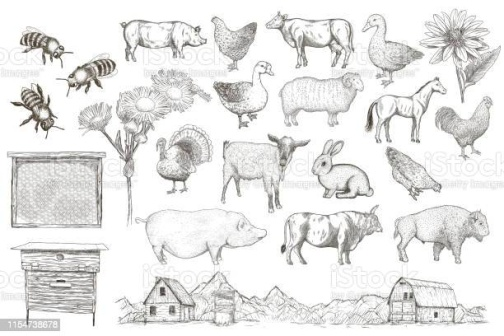Can you tell me more about the significance of the various animals depicted in the image? Absolutely! The animals in the image represent different aspects of farm life, each serving an essential purpose.

The bee is crucial for pollination, which helps crops and flowers grow. The cow provides milk, meat, and sometimes labor for farming tasks. Chickens contribute by laying eggs and also helping control pests. Pigs offer meat and are also known for their intelligence. Sheep provide wool, meat, and milk. The goose can lay eggs and provide meat, but they also act as natural alarms due to their loud honking.

Together, these animals create a balanced ecosystem, each playing a role in maintaining the sustainability and productivity of the farm. 